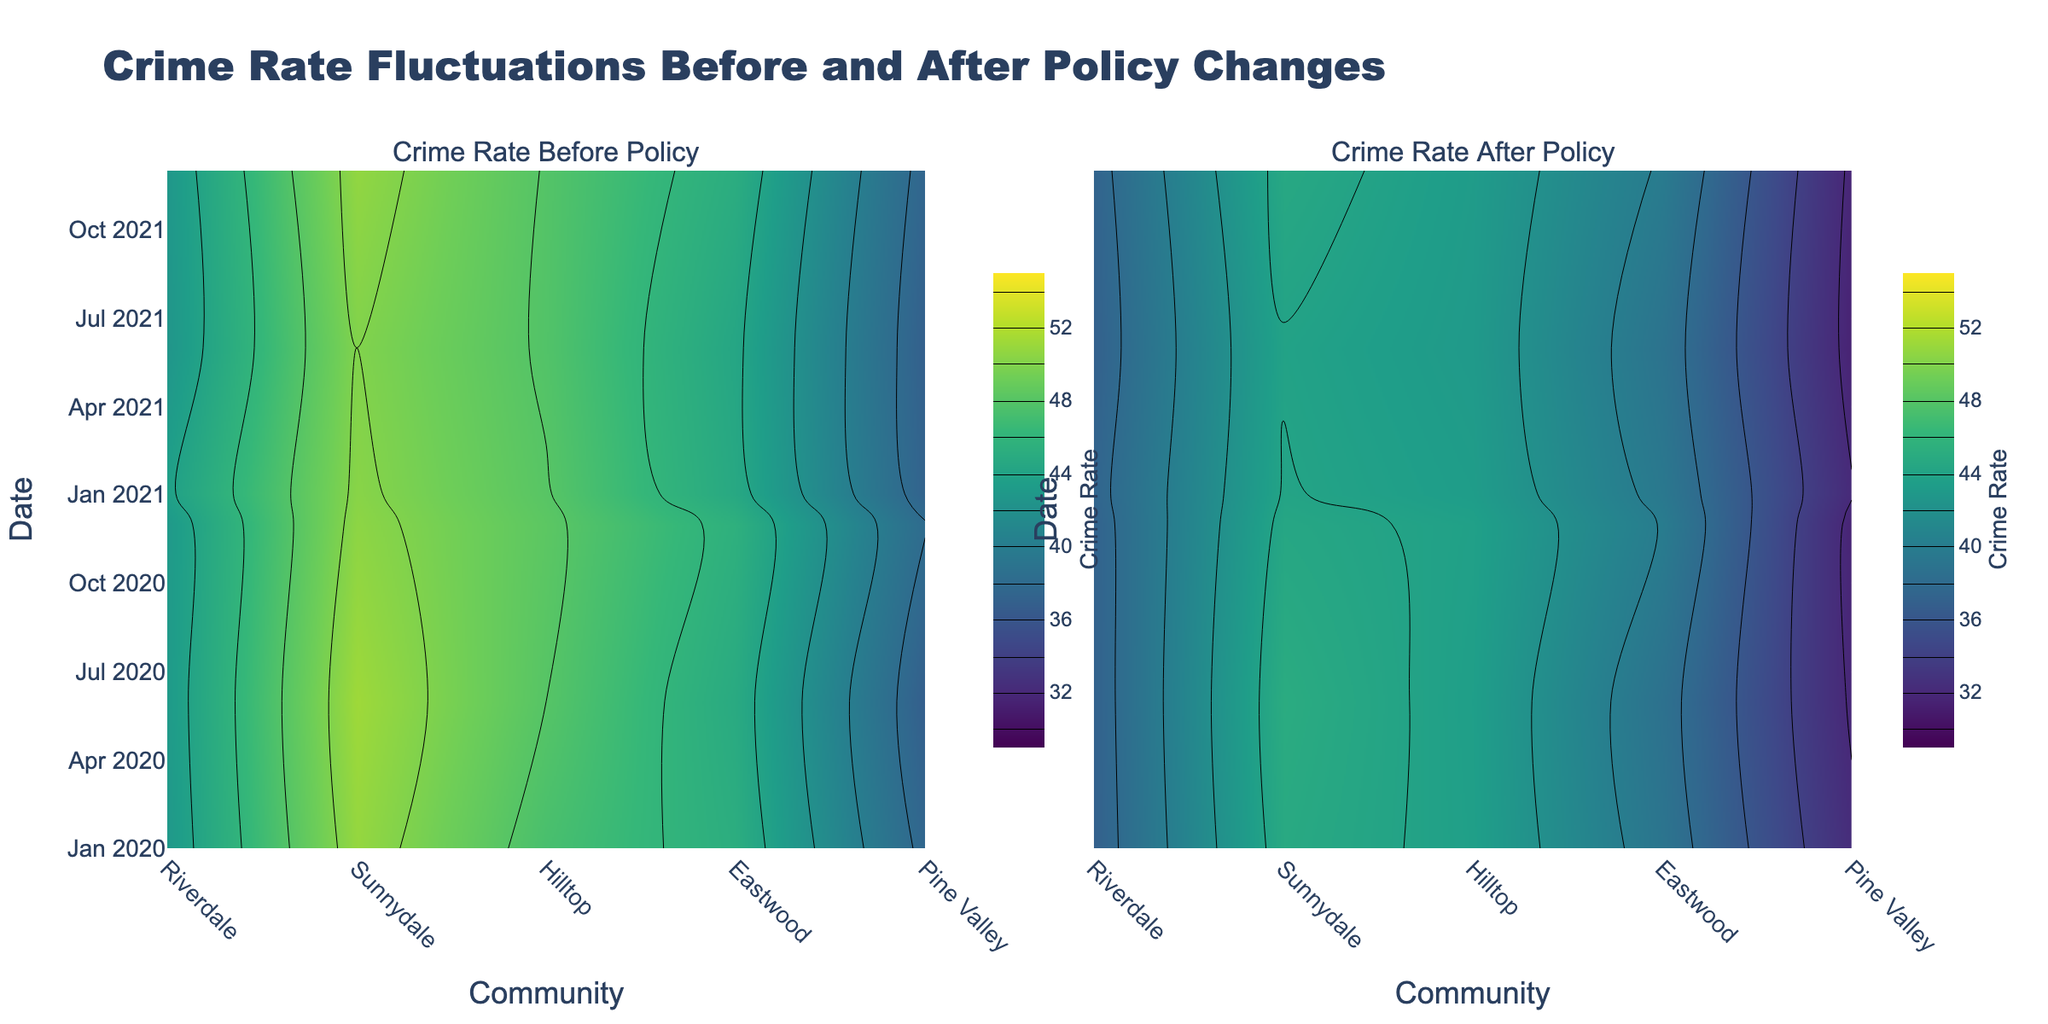What is the title of the figure? The title is written at the top of the figure, stating the overall theme or topic of the visualization. By reading the text at the top center, you can identify the title.
Answer: Crime Rate Fluctuations Before and After Policy Changes Which community had the highest crime rate before the policy was implemented around mid-2021? By looking at the contour plot under "Crime Rate Before Policy" for mid-2021, you can see the color with the highest value. Cross-reference the axis labels to determine the community.
Answer: Hilltop How much did the crime rate decrease in Riverdale from before to after the policy change around January 2021? Check both subplots for the crime rates in Riverdale around January 2021. Subtract the value in "Crime Rate After Policy" from "Crime Rate Before Policy."
Answer: 5.1 Which date had the lowest crime rate after the policy implementation in Pine Valley? Look at the "Crime Rate After Policy" subplot. Identify the date where the color representing the lowest crime rate is present for Pine Valley by referencing the y-axis.
Answer: June 2021 Compare the reduction in crime rates before and after the policy change in Sunnydale and Hilltop around mid-2020. Which community had a greater reduction? Check the crime rates from both subplots for Sunnydale and Hilltop around mid-2020. Calculate the difference for both and compare them.
Answer: Hilltop What general trend can be observed regarding crime rates before and after the policy implementation? By comparing the general color gradients and their respective values in both subplots, you can observe if there is a consistent trend in crime rate changes.
Answer: Decrease in crime rates What was the approximate crime rate in Eastwood before the policy change in December 2020? Look at the contour "Crime Rate Before Policy" and locate December 2020 on the y-axis. Trace horizontally to find Eastwood and read the crime rate using the color scale.
Answer: 43.0 